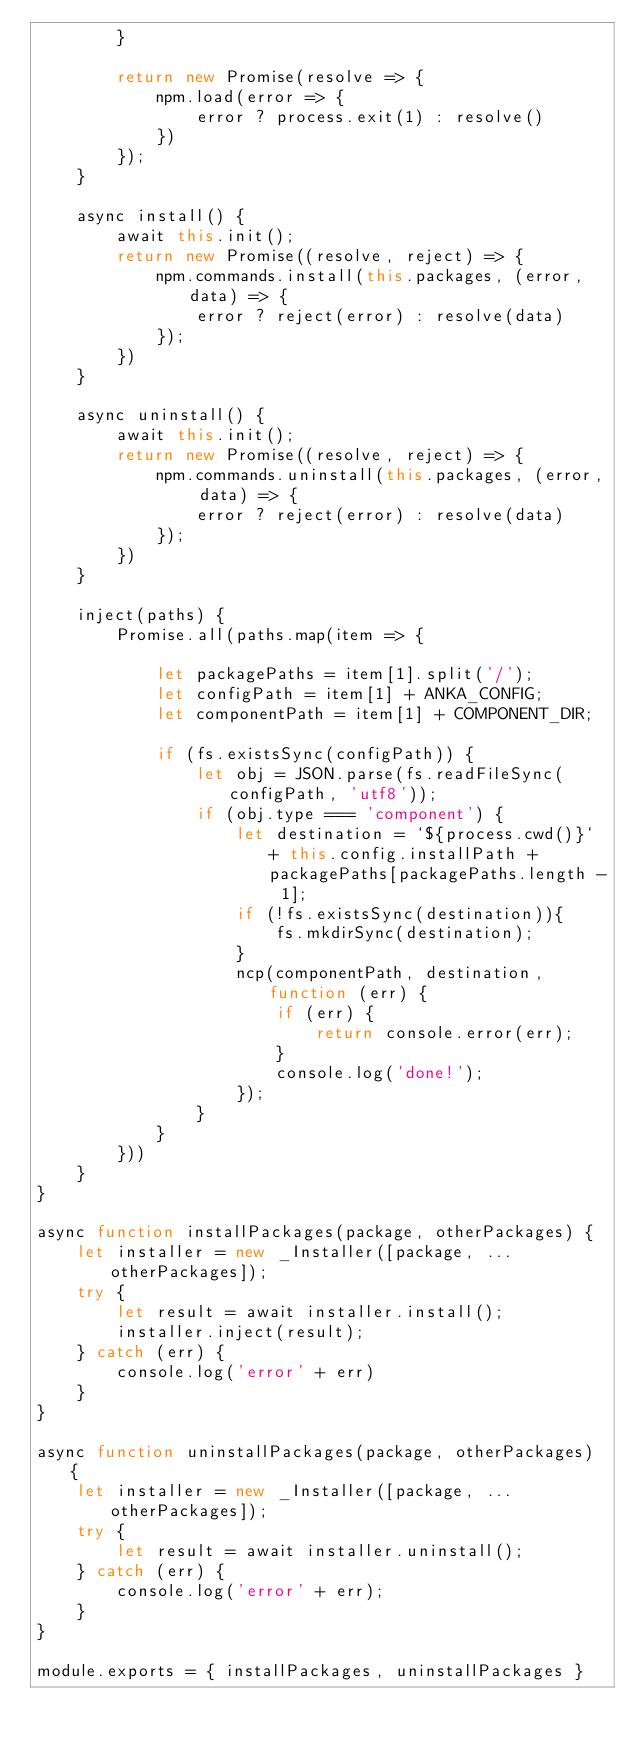Convert code to text. <code><loc_0><loc_0><loc_500><loc_500><_JavaScript_>		}

		return new Promise(resolve => {
			npm.load(error => {
				error ? process.exit(1) : resolve()
			}) 
		});
	}

	async install() {
		await this.init();
		return new Promise((resolve, reject) => {
			npm.commands.install(this.packages, (error, data) => {
				error ? reject(error) : resolve(data)
			});
		})
	}

	async uninstall() {
		await this.init();
		return new Promise((resolve, reject) => {
			npm.commands.uninstall(this.packages, (error, data) => {
				error ? reject(error) : resolve(data)
			});
		}) 
	}

	inject(paths) {
		Promise.all(paths.map(item => {

			let packagePaths = item[1].split('/');
			let configPath = item[1] + ANKA_CONFIG;
			let componentPath = item[1] + COMPONENT_DIR;

			if (fs.existsSync(configPath)) {
				let obj = JSON.parse(fs.readFileSync(configPath, 'utf8'));
				if (obj.type === 'component') {
					let destination = `${process.cwd()}` + this.config.installPath + packagePaths[packagePaths.length - 1];
					if (!fs.existsSync(destination)){
					    fs.mkdirSync(destination);
					}
					ncp(componentPath, destination, function (err) {
						if (err) {
							return console.error(err);
						}
						console.log('done!');
					});
				}
			}
		})) 
	}
}

async function installPackages(package, otherPackages) {
	let installer = new _Installer([package, ...otherPackages]);
	try {
		let result = await installer.install();
		installer.inject(result);
	} catch (err) {
		console.log('error' + err)
	}
}

async function uninstallPackages(package, otherPackages) {
	let installer = new _Installer([package, ...otherPackages]);
	try {
		let result = await installer.uninstall();
	} catch (err) {
		console.log('error' + err);
	}
}

module.exports = { installPackages, uninstallPackages }</code> 